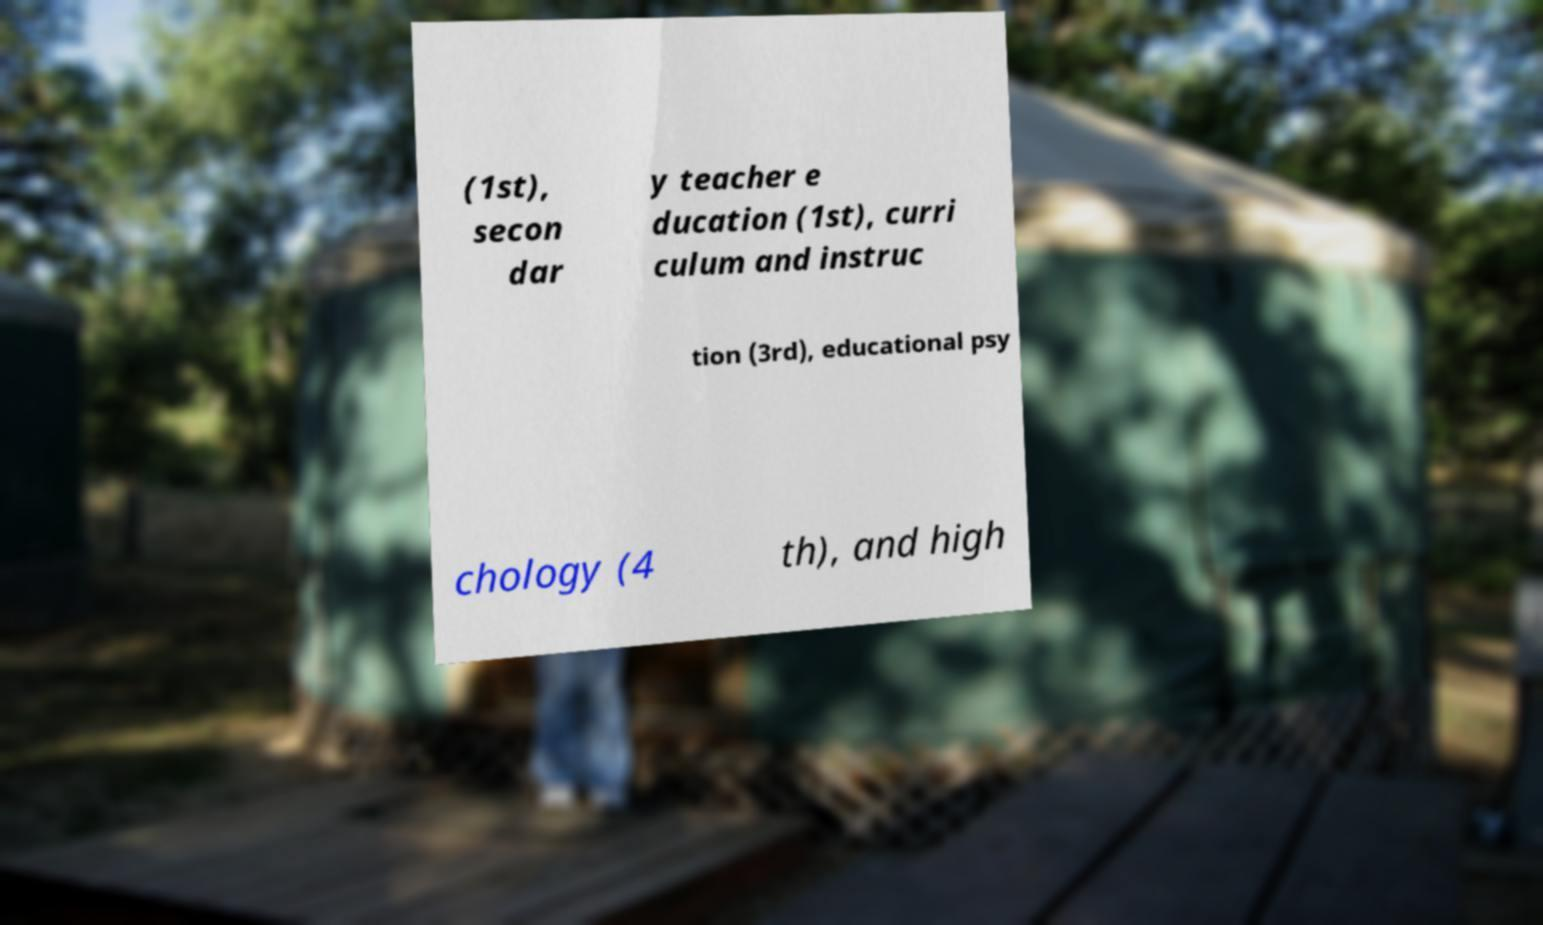Could you assist in decoding the text presented in this image and type it out clearly? (1st), secon dar y teacher e ducation (1st), curri culum and instruc tion (3rd), educational psy chology (4 th), and high 